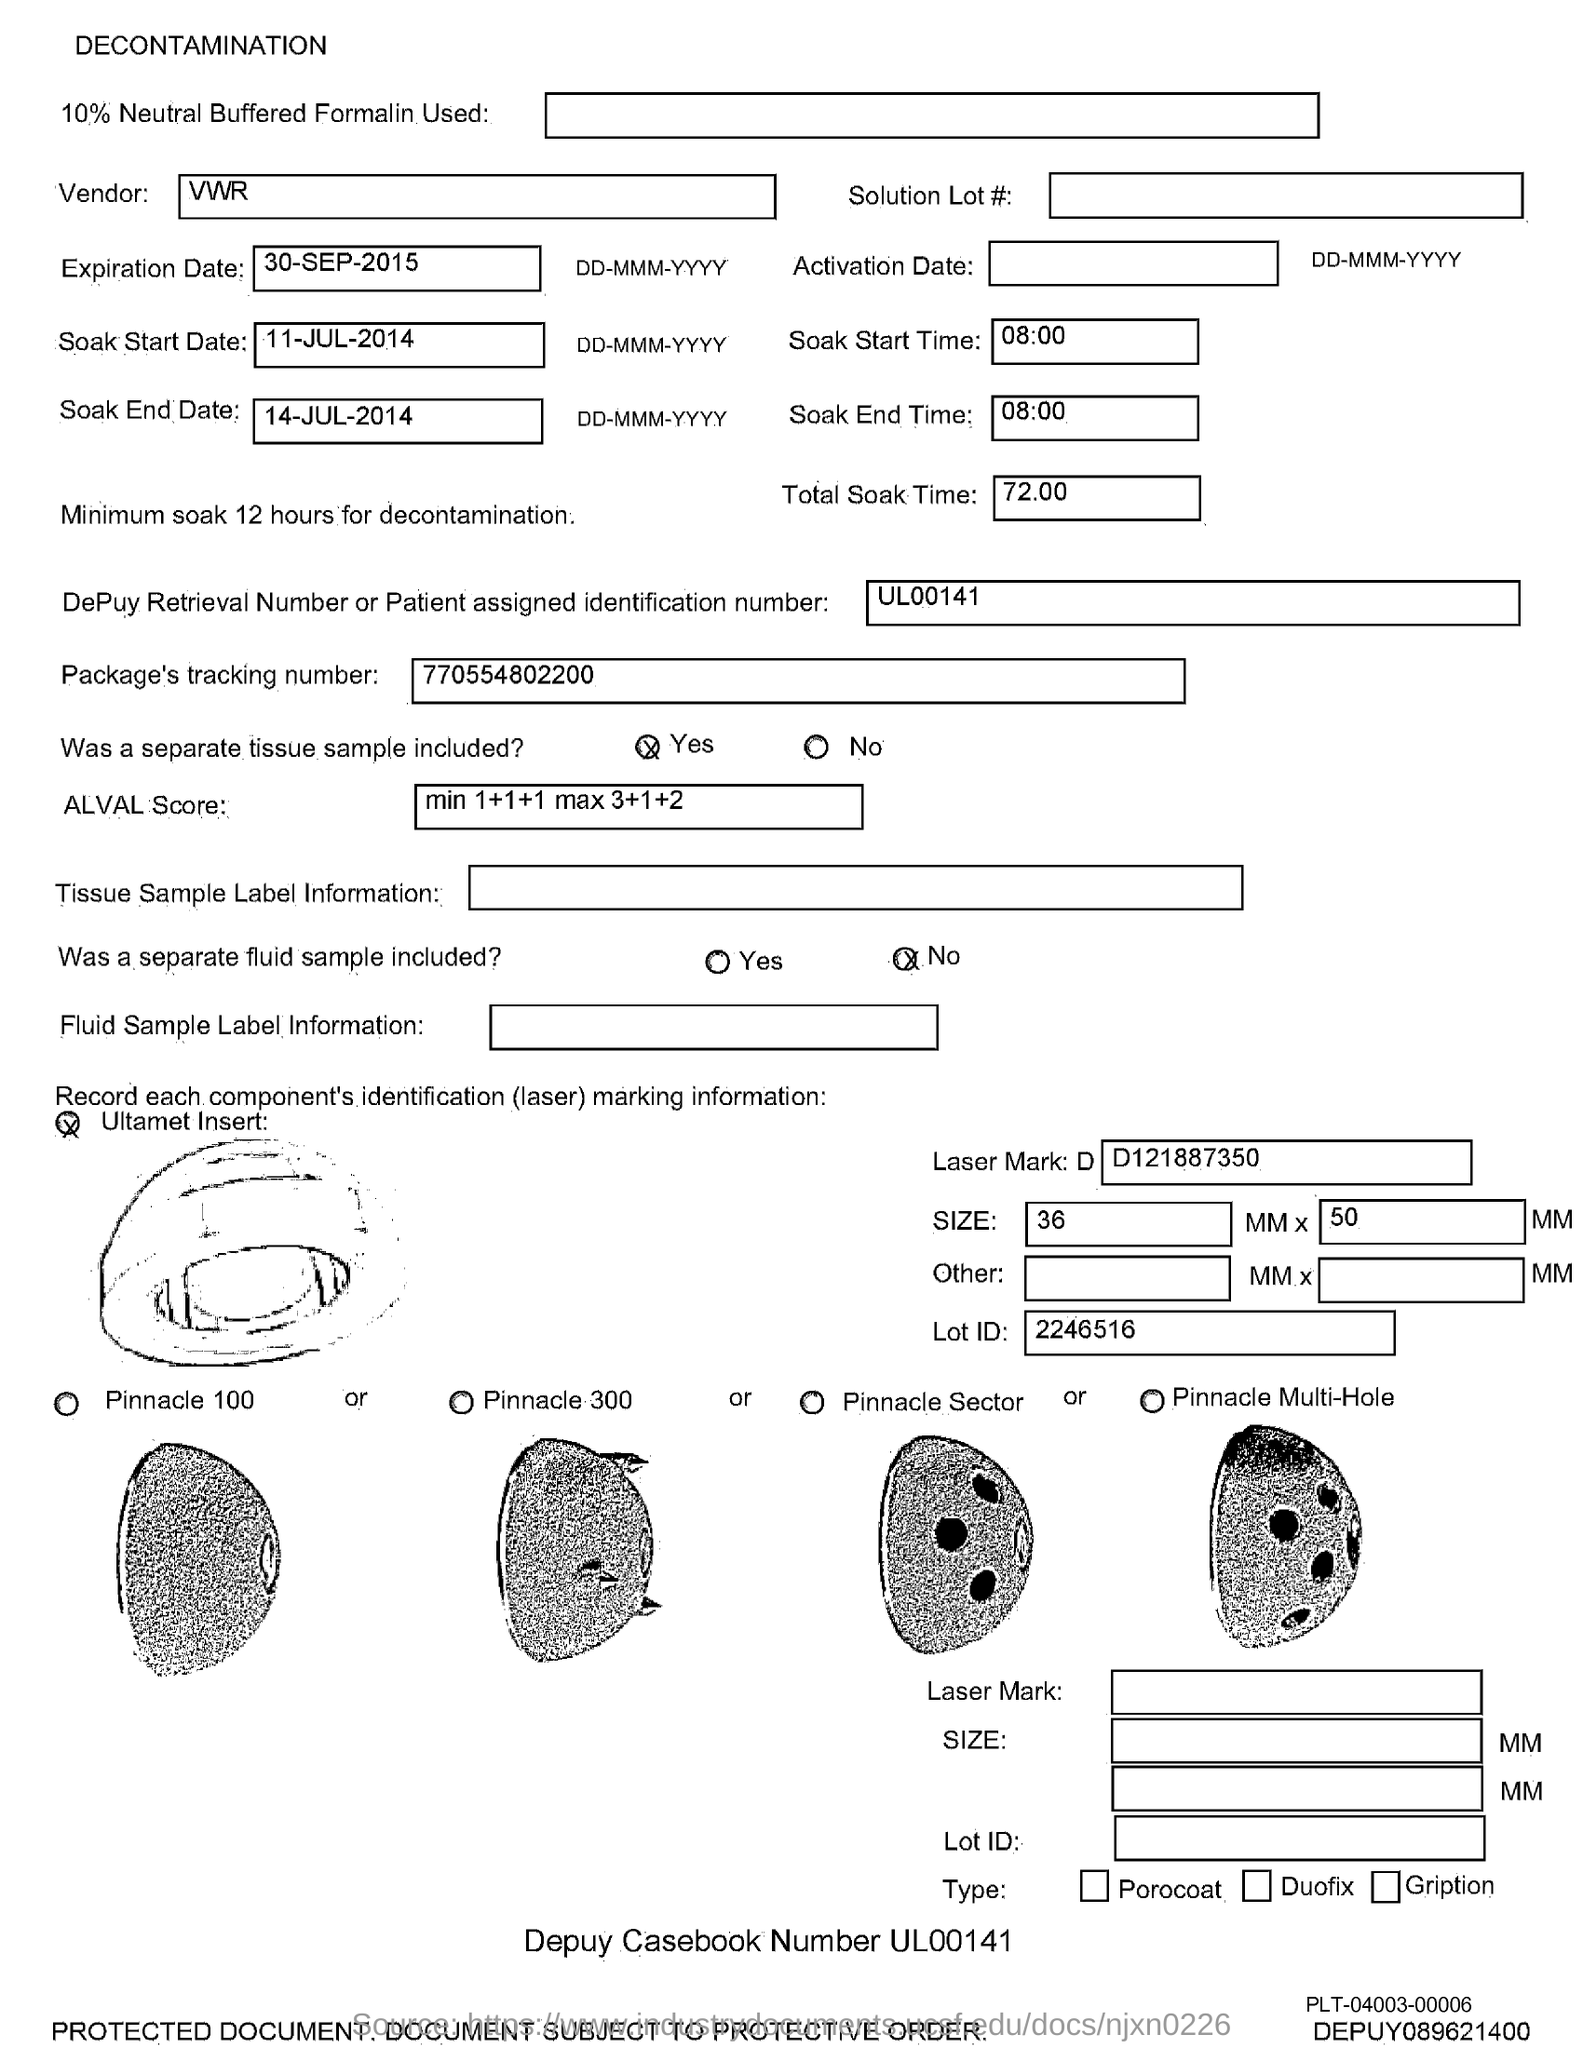List a handful of essential elements in this visual. The Lot ID is 2246516... The soak time is 72.00 hours. The tracking number "770554802200..." is associated with a package. The soak start time is 8:00 a.m. I'm sorry, but the text you provided is not a complete sentence and it is not clear what you are trying to ask. Could you please provide more context or clarify your question? 